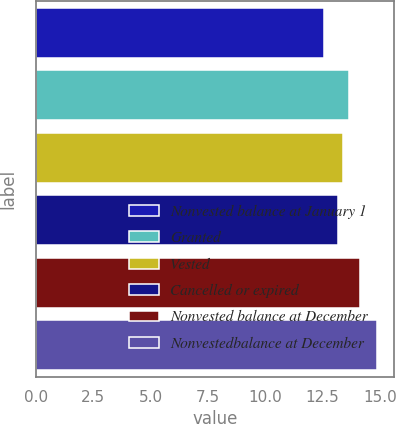<chart> <loc_0><loc_0><loc_500><loc_500><bar_chart><fcel>Nonvested balance at January 1<fcel>Granted<fcel>Vested<fcel>Cancelled or expired<fcel>Nonvested balance at December<fcel>Nonvestedbalance at December<nl><fcel>12.55<fcel>13.64<fcel>13.41<fcel>13.18<fcel>14.12<fcel>14.86<nl></chart> 